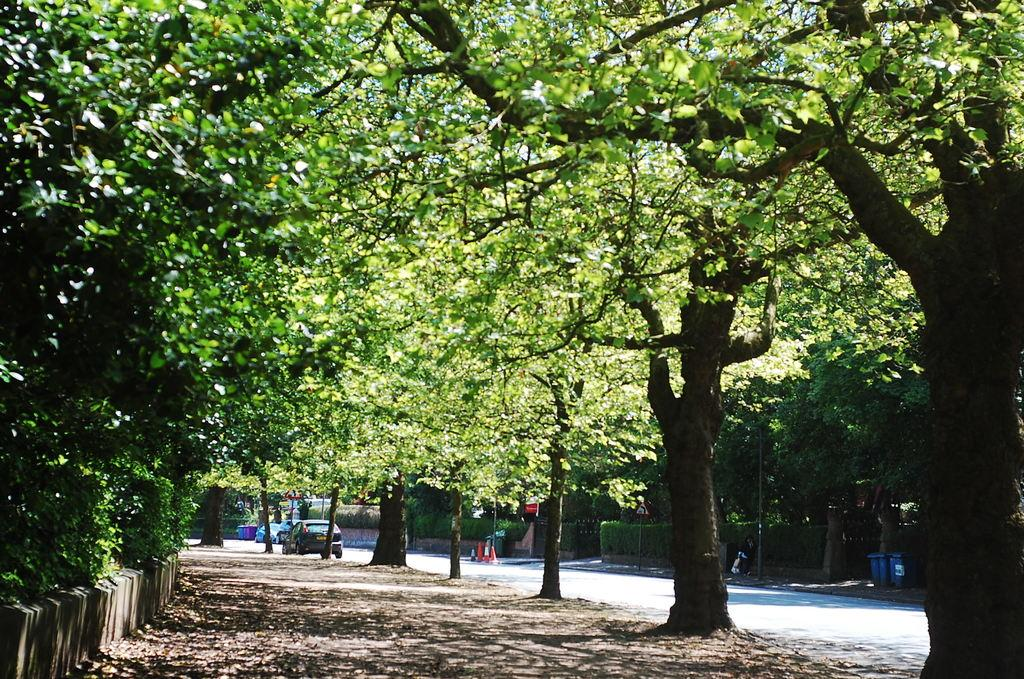What type of vegetation can be seen in the image? There are trees and plants in the image. What objects are present for waste disposal? There are dustbins in the image. What objects are used to direct traffic or mark hazards? There are traffic cones in the image. What type of vehicles can be seen in the image? There are cars in the image. What type of structures can be seen in the background of the image? There are houses in the background of the image. Can you tell me how many bulbs are illuminating the trees in the image? There is no mention of bulbs or illumination in the image; it only features trees, plants, dustbins, traffic cones, cars, and houses. What type of knee support is visible on the cars in the image? There is no mention of knee support or any body parts in the image; it only features trees, plants, dustbins, traffic cones, cars, and houses. 